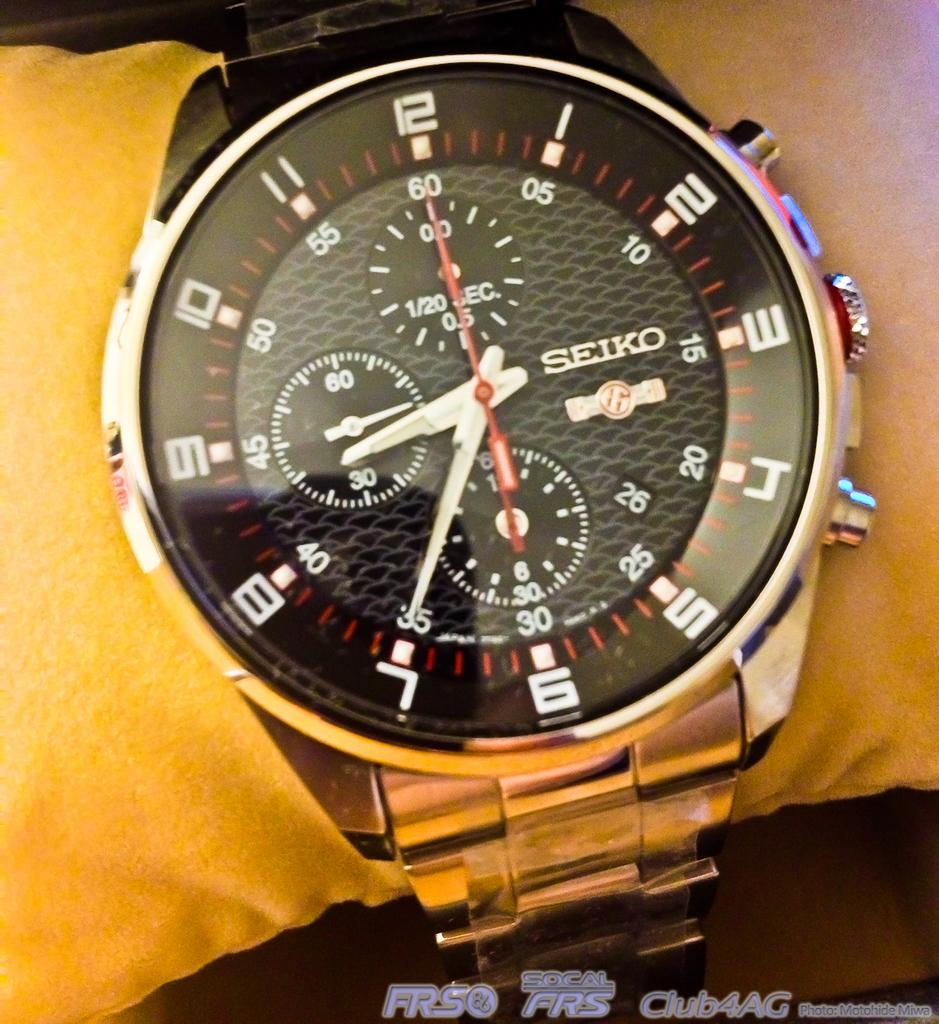<image>
Relay a brief, clear account of the picture shown. a Seiko watch with red lines for the minutes is on a persons wrist 